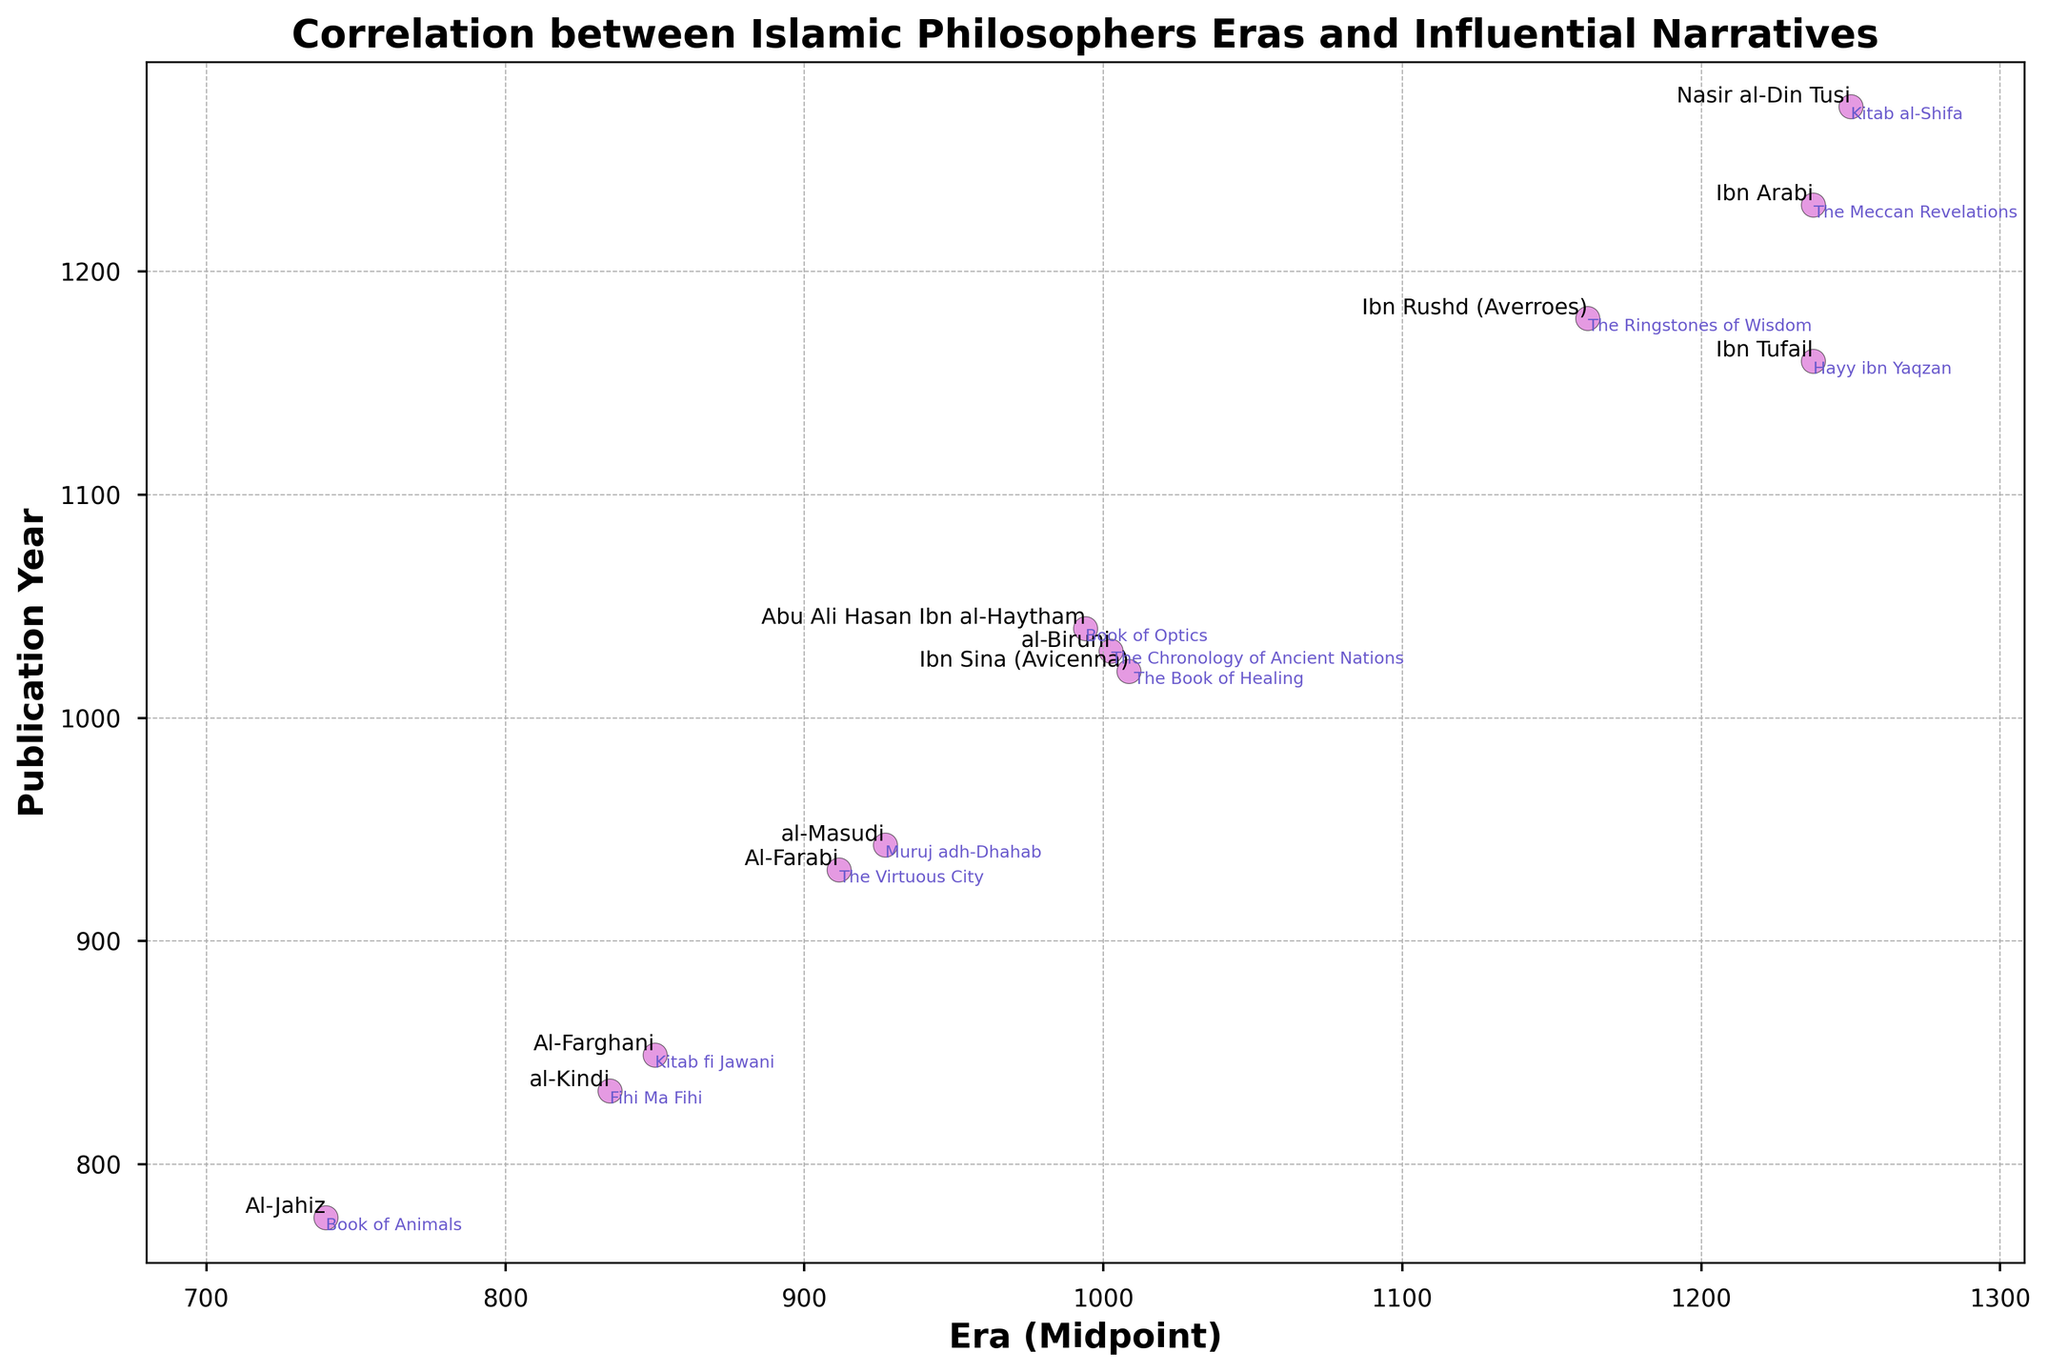Which philosopher's influential narrative was published closest to the midpoint of their era? To identify which philosopher’s narrative was closest to the midpoint of their era, find the difference between each publication year and the midpoint of their era. The data point with the smallest difference is the closest. Based on the figure, Ibn Tufail's "Hayy ibn Yaqzan" (1160) is closest to his era’s midpoint (1237.5).
Answer: Ibn Tufail Are there more influential narratives published before or after 1000 CE? Count the number of narratives published before and after 1000 CE. The figure shows 4 narratives before and 7 narratives after 1000 CE.
Answer: After Which philosopher had their work published the latest in history? To determine the latest publication, look for the data point with the highest publication year value. The figure indicates Nasir al-Din Tusi's "Kitab al-Shifa" in 1274 is the most recent.
Answer: Nasir al-Din Tusi How many years after Ibn Sina did al-Biruni publish his influential narrative? Subtract Ibn Sina's publication year (1021) from al-Biruni's publication year (1030). The difference is 9 years.
Answer: 9 years Which era has the widest range among the philosophers shown? Calculate the range of each era by subtracting the start year from the end year. The era with the largest range belongs to Ibn Sina (980-1037), which spans 57 years.
Answer: 57 years (Ibn Sina) Are there any philosophers whose publication year is exactly at the midpoint of their era? Check if any publication year matches the calculated midpoint of their era. Upon inspection, none of the philosophers' publication years align perfectly with their era's midpoint.
Answer: None Which era had the least number of philosophers contributing influential narratives? By visually inspecting the scatter plot, identify the era with the fewest data points. The era 700-780 (Al-Jahiz) had only one philosopher.
Answer: 700-780 (Al-Jahiz) Compare the publication years of philosophers Ibn Rushd and Ibn Arabi. Which one published their narrative first? By comparing the publication years of Ibn Rushd (1179) and Ibn Arabi (1230), Ibn Rushd’s narrative was published first.
Answer: Ibn Rushd Which philosopher’s influential narrative was published closest to the year 1000 CE? To find the closest publication to 1000 CE, calculate the absolute difference from 1000 CE for each narrative. Al-Biruni's "The Chronology of Ancient Nations" (1030) is closest, with a difference of 30 years.
Answer: al-Biruni 